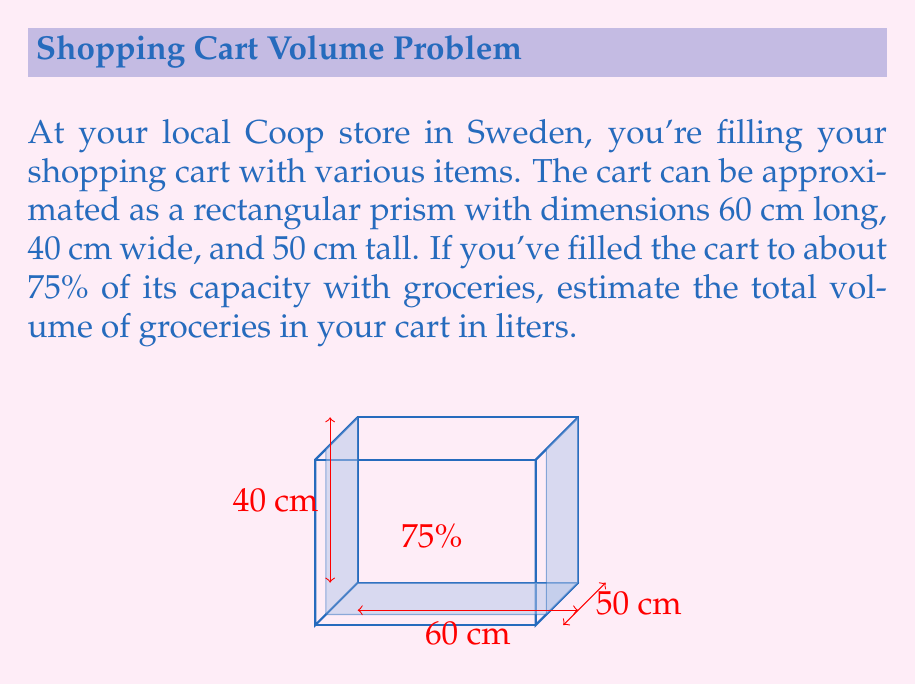What is the answer to this math problem? Let's approach this step-by-step:

1) First, calculate the total volume of the shopping cart:
   $$ V_{cart} = length \times width \times height $$
   $$ V_{cart} = 60 \text{ cm} \times 40 \text{ cm} \times 50 \text{ cm} = 120,000 \text{ cm}^3 $$

2) The groceries fill 75% of this volume:
   $$ V_{groceries} = 75\% \times V_{cart} = 0.75 \times 120,000 \text{ cm}^3 = 90,000 \text{ cm}^3 $$

3) Convert cubic centimeters to liters:
   $$ 1 \text{ L} = 1000 \text{ cm}^3 $$
   $$ V_{groceries} \text{ in liters} = \frac{90,000 \text{ cm}^3}{1000 \text{ cm}^3/\text{L}} = 90 \text{ L} $$

Therefore, the estimated volume of groceries in your Coop shopping cart is 90 liters.
Answer: 90 L 